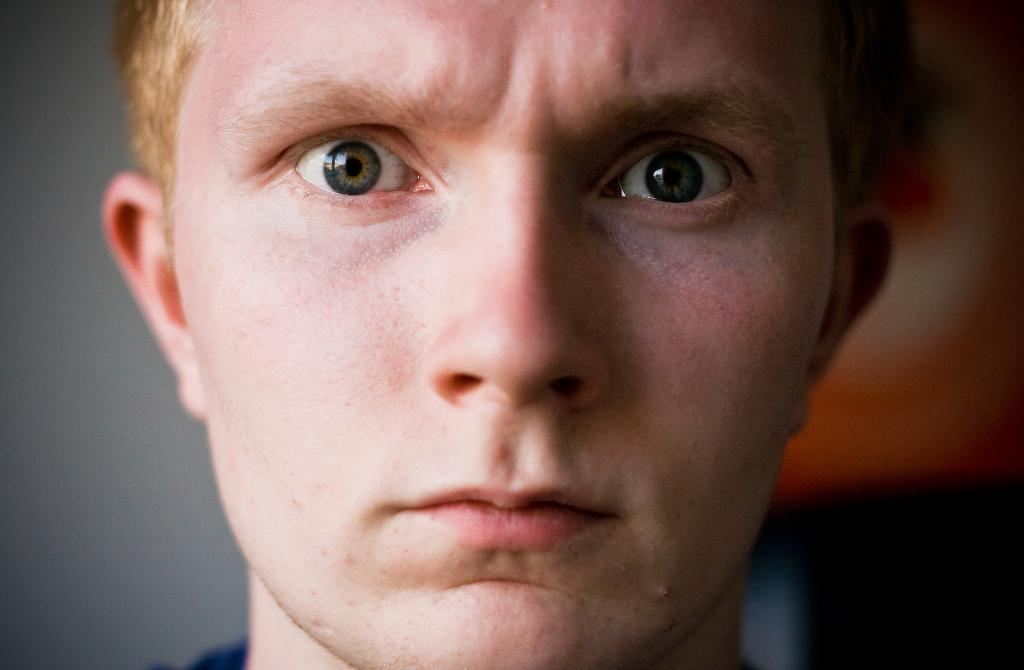What is the main subject of the image? There is a man's face in the image. Can you describe the background of the image? The background is blurred. What type of kettle can be seen in the background of the image? There is no kettle present in the image; the background is blurred. What behavior is the man exhibiting in the image? The image only shows the man's face, so it is not possible to determine his behavior from the image alone. 